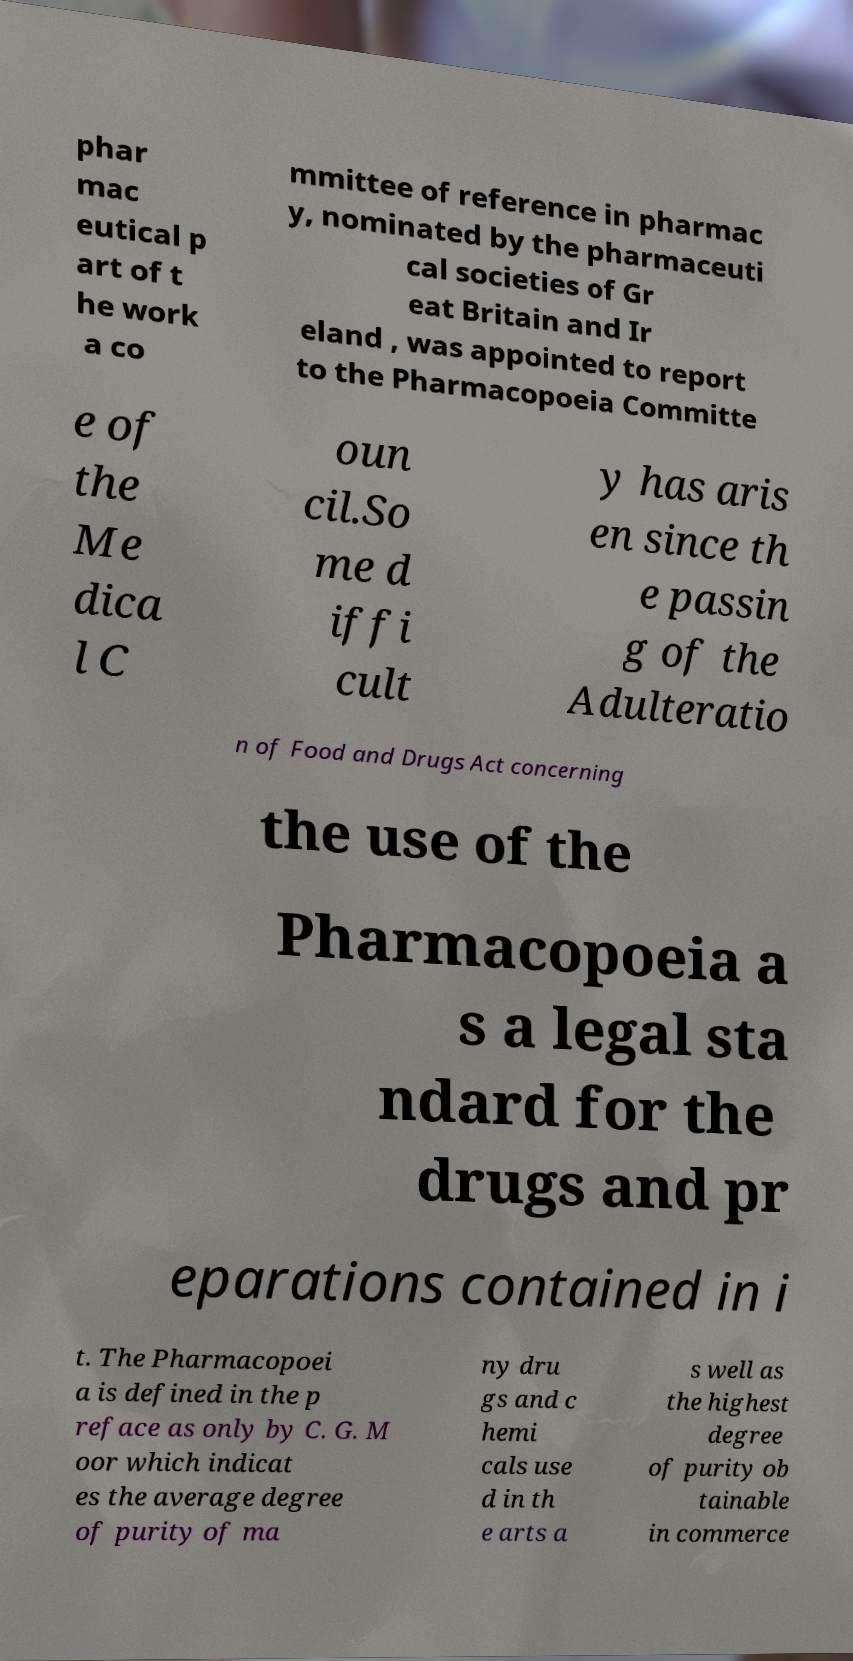Could you extract and type out the text from this image? phar mac eutical p art of t he work a co mmittee of reference in pharmac y, nominated by the pharmaceuti cal societies of Gr eat Britain and Ir eland , was appointed to report to the Pharmacopoeia Committe e of the Me dica l C oun cil.So me d iffi cult y has aris en since th e passin g of the Adulteratio n of Food and Drugs Act concerning the use of the Pharmacopoeia a s a legal sta ndard for the drugs and pr eparations contained in i t. The Pharmacopoei a is defined in the p reface as only by C. G. M oor which indicat es the average degree of purity of ma ny dru gs and c hemi cals use d in th e arts a s well as the highest degree of purity ob tainable in commerce 